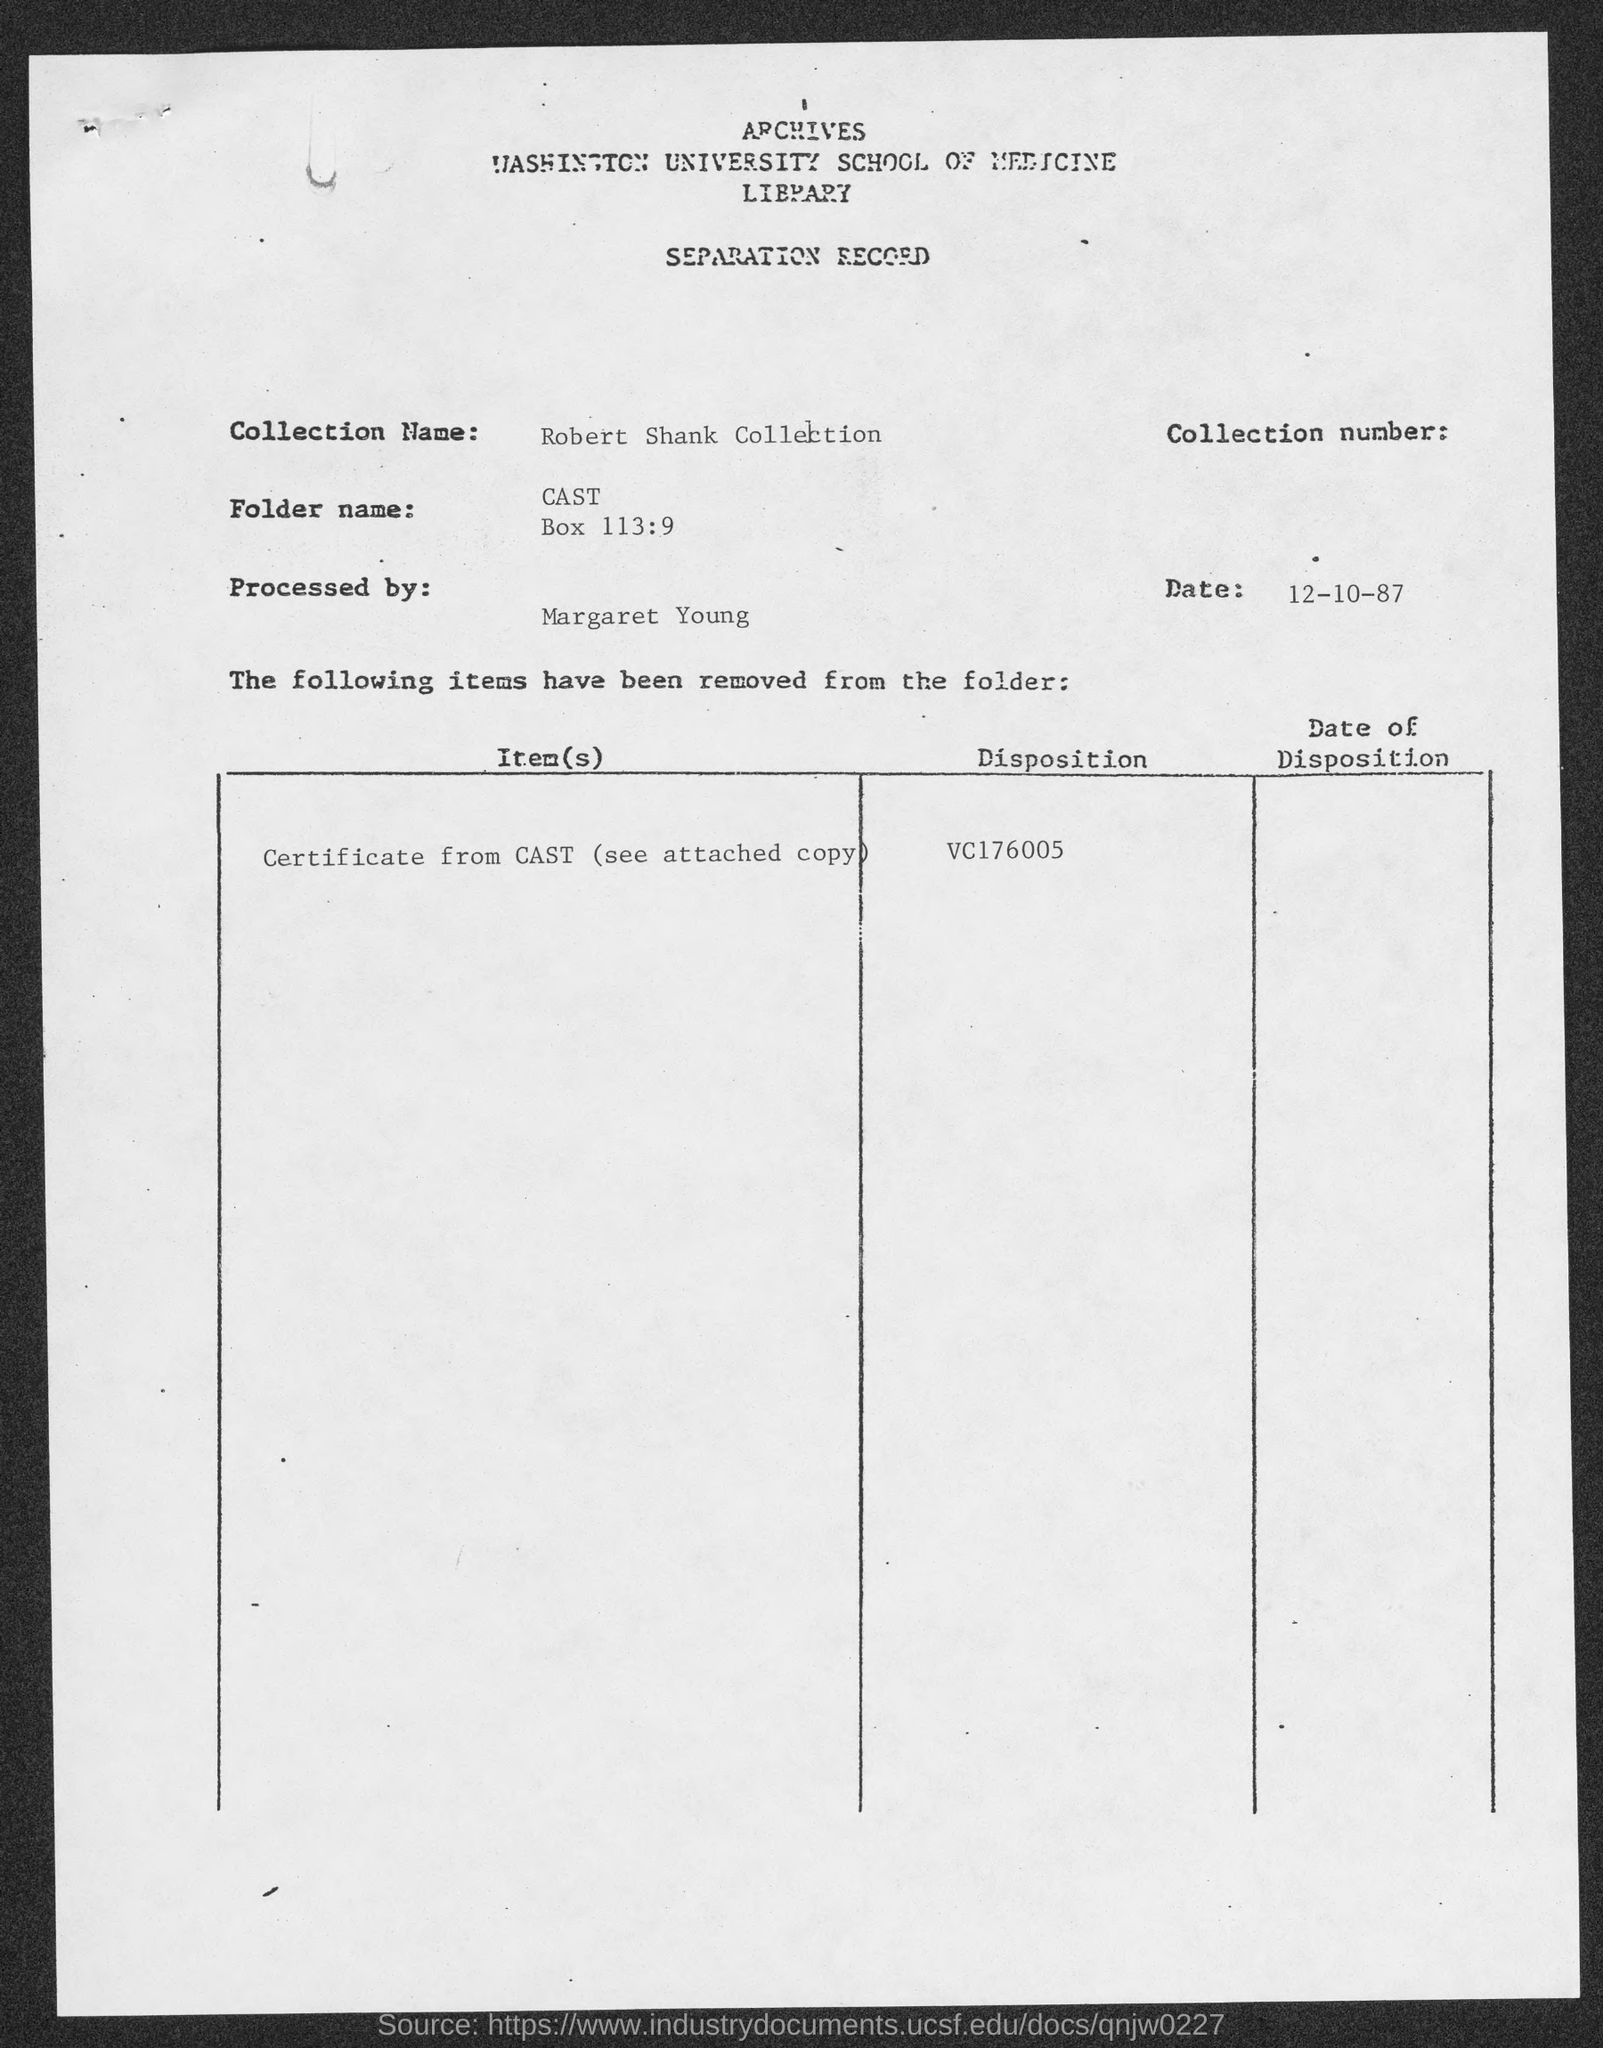Identify some key points in this picture. The date mentioned in the separation record is 12-10-87. The collection name listed in the separation record is the Robert Shank Collection. 